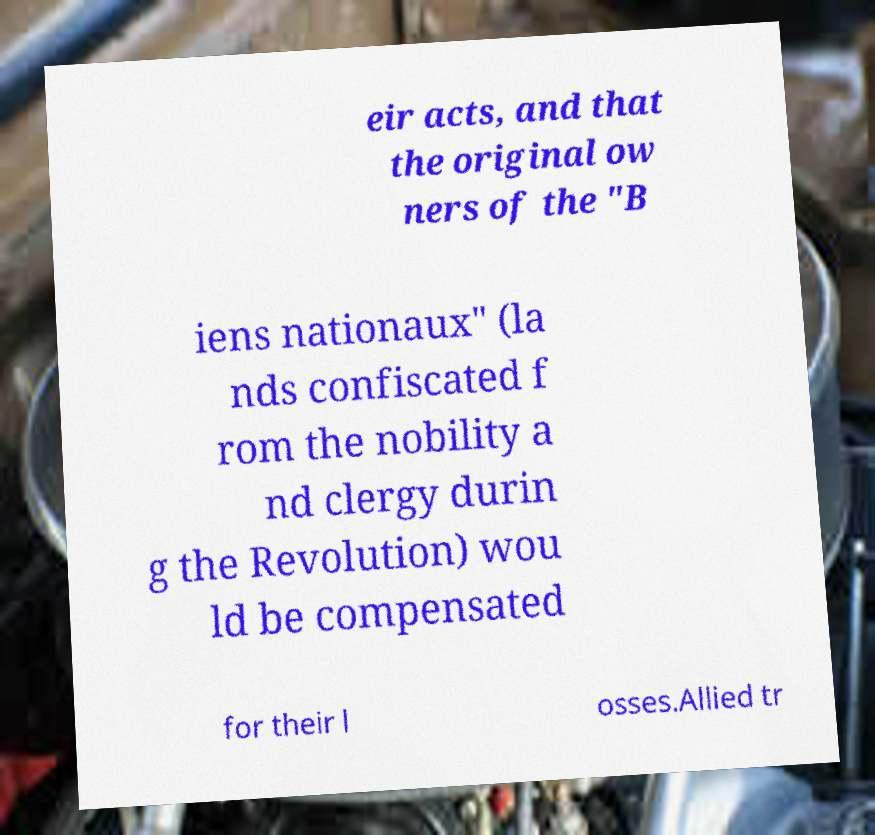Please identify and transcribe the text found in this image. eir acts, and that the original ow ners of the "B iens nationaux" (la nds confiscated f rom the nobility a nd clergy durin g the Revolution) wou ld be compensated for their l osses.Allied tr 